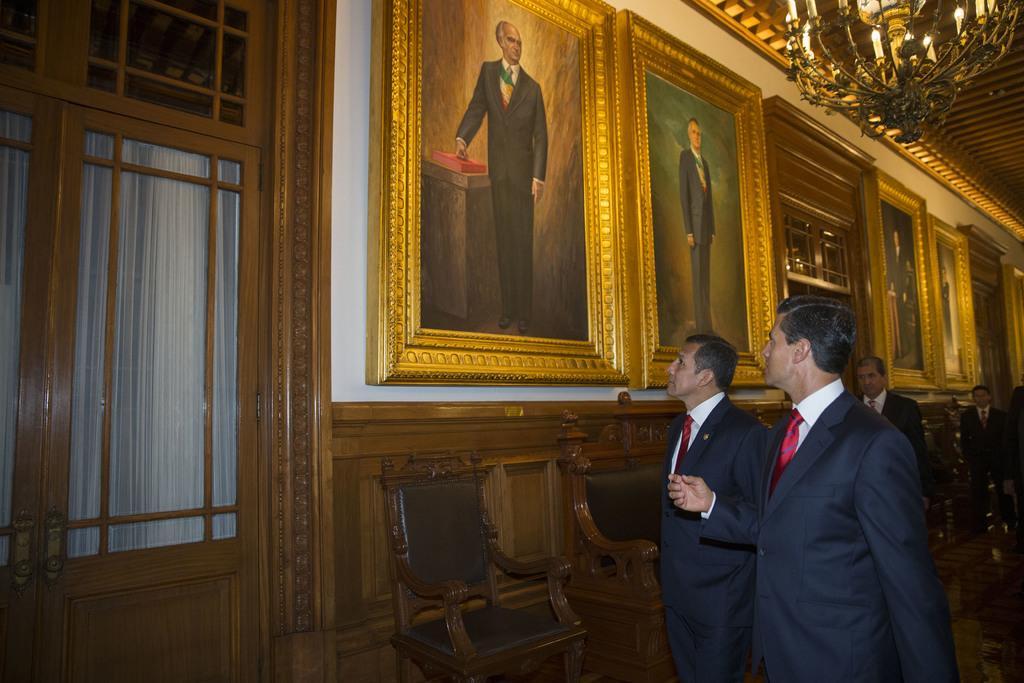Can you describe this image briefly? The image is inside the room. In the image there are group people standing in front of a photo frames and we can also see chairs, on left side there is a door which is closed. On top there is a roof with few lights. 